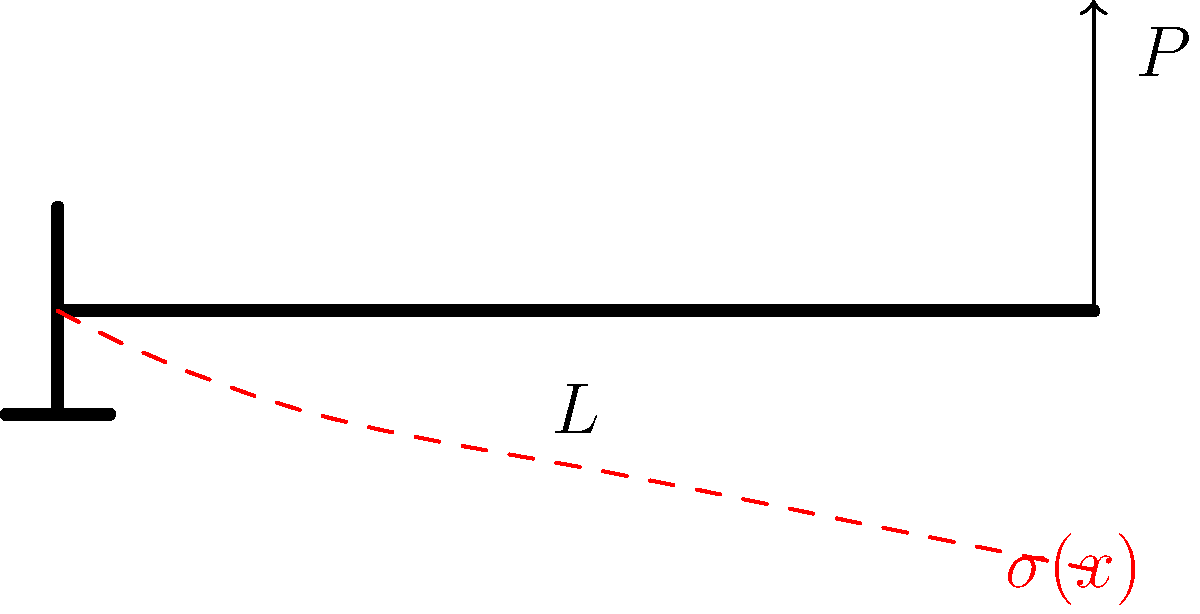As a filmmaker creating a visual interpretation of stress in engineering, how would you represent the maximum bending stress in a cantilever beam with a point load $P$ at its free end? Consider the beam's length $L$, cross-sectional moment of inertia $I$, and distance from the neutral axis to the outer fiber $c$. To visualize the maximum bending stress in a cantilever beam, we need to understand the stress distribution:

1. The bending moment $M(x)$ at any point $x$ along the beam is given by:
   $M(x) = P(L-x)$

2. The bending stress $\sigma(x)$ at any point is:
   $\sigma(x) = \frac{M(x)c}{I}$

3. Substituting the expression for $M(x)$:
   $\sigma(x) = \frac{P(L-x)c}{I}$

4. The maximum stress occurs at the fixed end $(x=0)$:
   $\sigma_{max} = \frac{PLc}{I}$

5. Visually, this would be represented as a linear stress distribution, with maximum stress at the fixed end and zero stress at the free end.

To create a compelling visual interpretation:
- Use color gradients to show stress intensity (e.g., red for high stress, blue for low stress)
- Incorporate dynamic elements to show how the stress changes along the beam's length
- Consider using exaggerated deformations to emphasize the beam's bending
Answer: $\sigma_{max} = \frac{PLc}{I}$ at the fixed end 